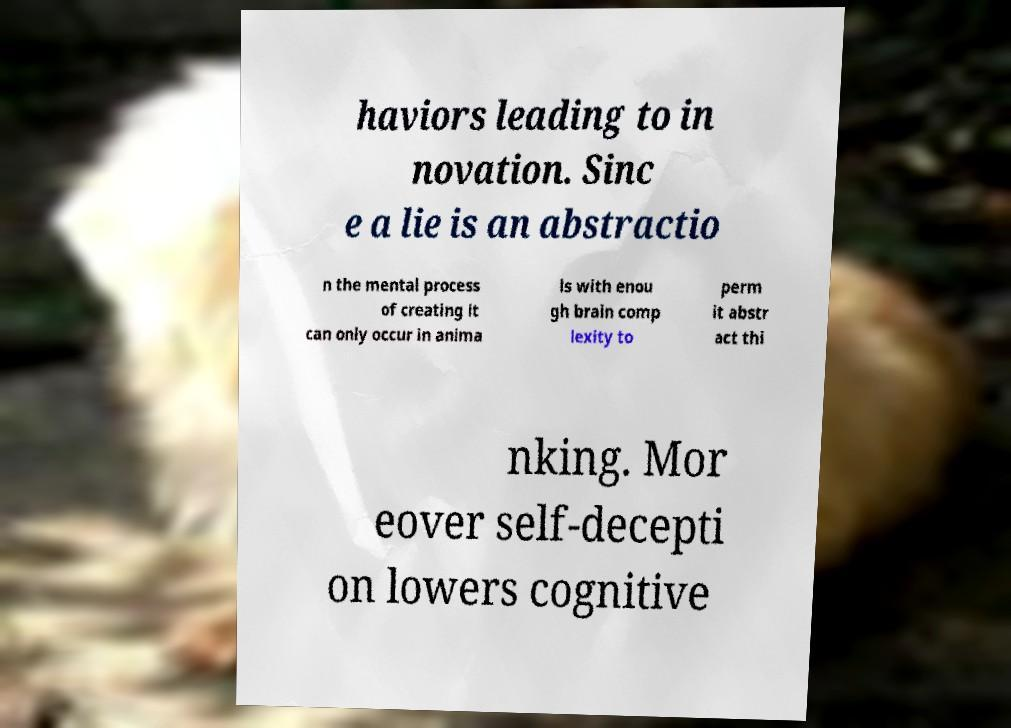Please identify and transcribe the text found in this image. haviors leading to in novation. Sinc e a lie is an abstractio n the mental process of creating it can only occur in anima ls with enou gh brain comp lexity to perm it abstr act thi nking. Mor eover self-decepti on lowers cognitive 